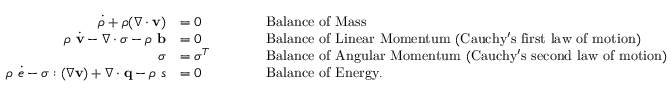Convert formula to latex. <formula><loc_0><loc_0><loc_500><loc_500>{ \begin{array} { r l r l } { { \dot { \rho } } + \rho ( { \nabla } \cdot v ) } & { = 0 } & & { \quad { B a l a n c e o f M a s s } } \\ { \rho { \dot { v } } - { \nabla } \cdot { \sigma } - \rho b } & { = 0 } & & { \quad { B a l a n c e o f L i n e a r M o m e n t u m ( C a u c h y ^ { \prime } s f i r s t l a w o f m o t i o n ) } } \\ { \sigma } & { = { \sigma } ^ { T } } & & { \quad { B a l a n c e o f A n g u l a r M o m e n t u m ( C a u c h y ^ { \prime } s s e c o n d l a w o f m o t i o n ) } } \\ { \rho { \dot { e } } - { \sigma } \colon ( { \nabla } v ) + { \nabla } \cdot q - \rho s } & { = 0 } & & { \quad { B a l a n c e o f E n e r g y . } } \end{array} }</formula> 